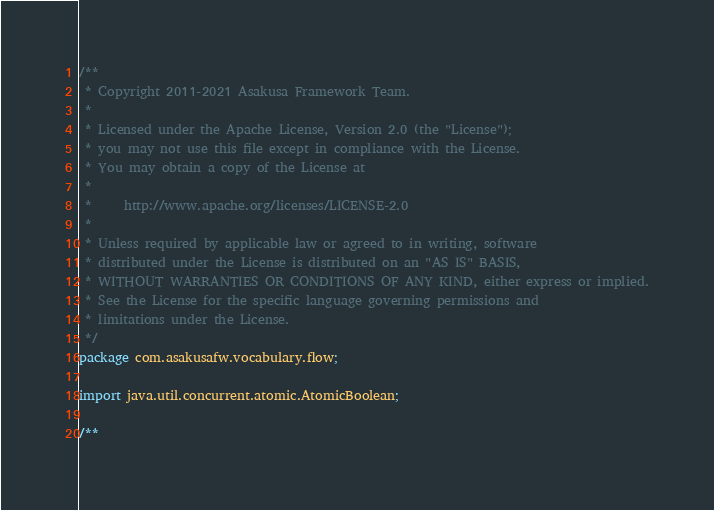Convert code to text. <code><loc_0><loc_0><loc_500><loc_500><_Java_>/**
 * Copyright 2011-2021 Asakusa Framework Team.
 *
 * Licensed under the Apache License, Version 2.0 (the "License");
 * you may not use this file except in compliance with the License.
 * You may obtain a copy of the License at
 *
 *     http://www.apache.org/licenses/LICENSE-2.0
 *
 * Unless required by applicable law or agreed to in writing, software
 * distributed under the License is distributed on an "AS IS" BASIS,
 * WITHOUT WARRANTIES OR CONDITIONS OF ANY KIND, either express or implied.
 * See the License for the specific language governing permissions and
 * limitations under the License.
 */
package com.asakusafw.vocabulary.flow;

import java.util.concurrent.atomic.AtomicBoolean;

/**</code> 